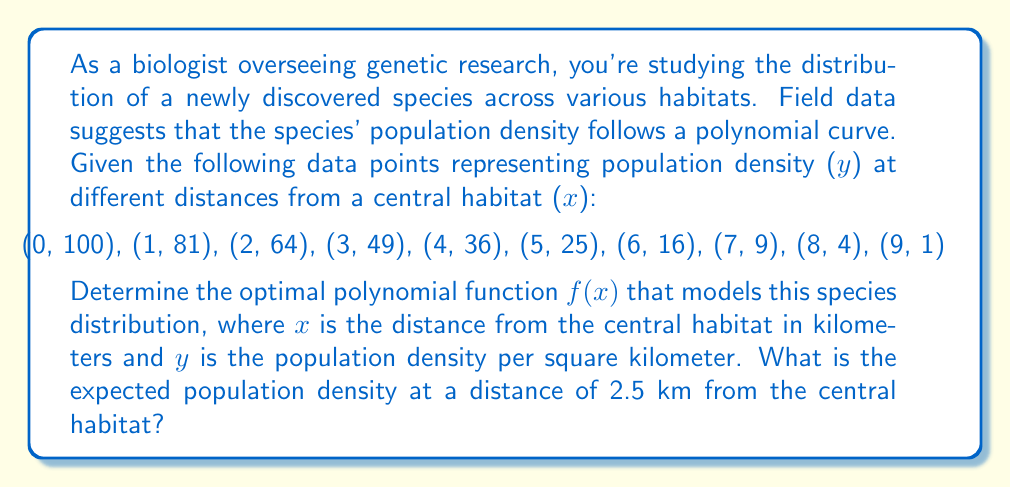Solve this math problem. To determine the optimal polynomial function for this species distribution, we'll follow these steps:

1) Observe the pattern in the data points. The y-values seem to be perfect squares decreasing as x increases, suggesting a quadratic function.

2) The general form of a quadratic function is $f(x) = ax^2 + bx + c$.

3) Given that $f(0) = 100$, we can deduce that $c = 100$.

4) Now, let's use the point (3, 49) to set up an equation:
   $49 = 9a + 3b + 100$

5) Use the point (9, 1) to set up another equation:
   $1 = 81a + 9b + 100$

6) Subtract the second equation from the first:
   $48 = -72a - 6b$
   $8 = -12a - b$

7) From the pattern, we can guess that $a = -1$ and $b = -4$. Let's verify:
   $8 = -12(-1) - (-4)$
   $8 = 12 - 4 = 8$ (This checks out)

8) Therefore, our optimal polynomial function is:
   $f(x) = -x^2 - 4x + 100$

9) To find the expected population density at 2.5 km:
   $f(2.5) = -(2.5)^2 - 4(2.5) + 100$
   $= -6.25 - 10 + 100$
   $= 83.75$

Thus, the expected population density at 2.5 km from the central habitat is 83.75 per square kilometer.
Answer: The optimal polynomial function is $f(x) = -x^2 - 4x + 100$, and the expected population density at 2.5 km from the central habitat is 83.75 per square kilometer. 